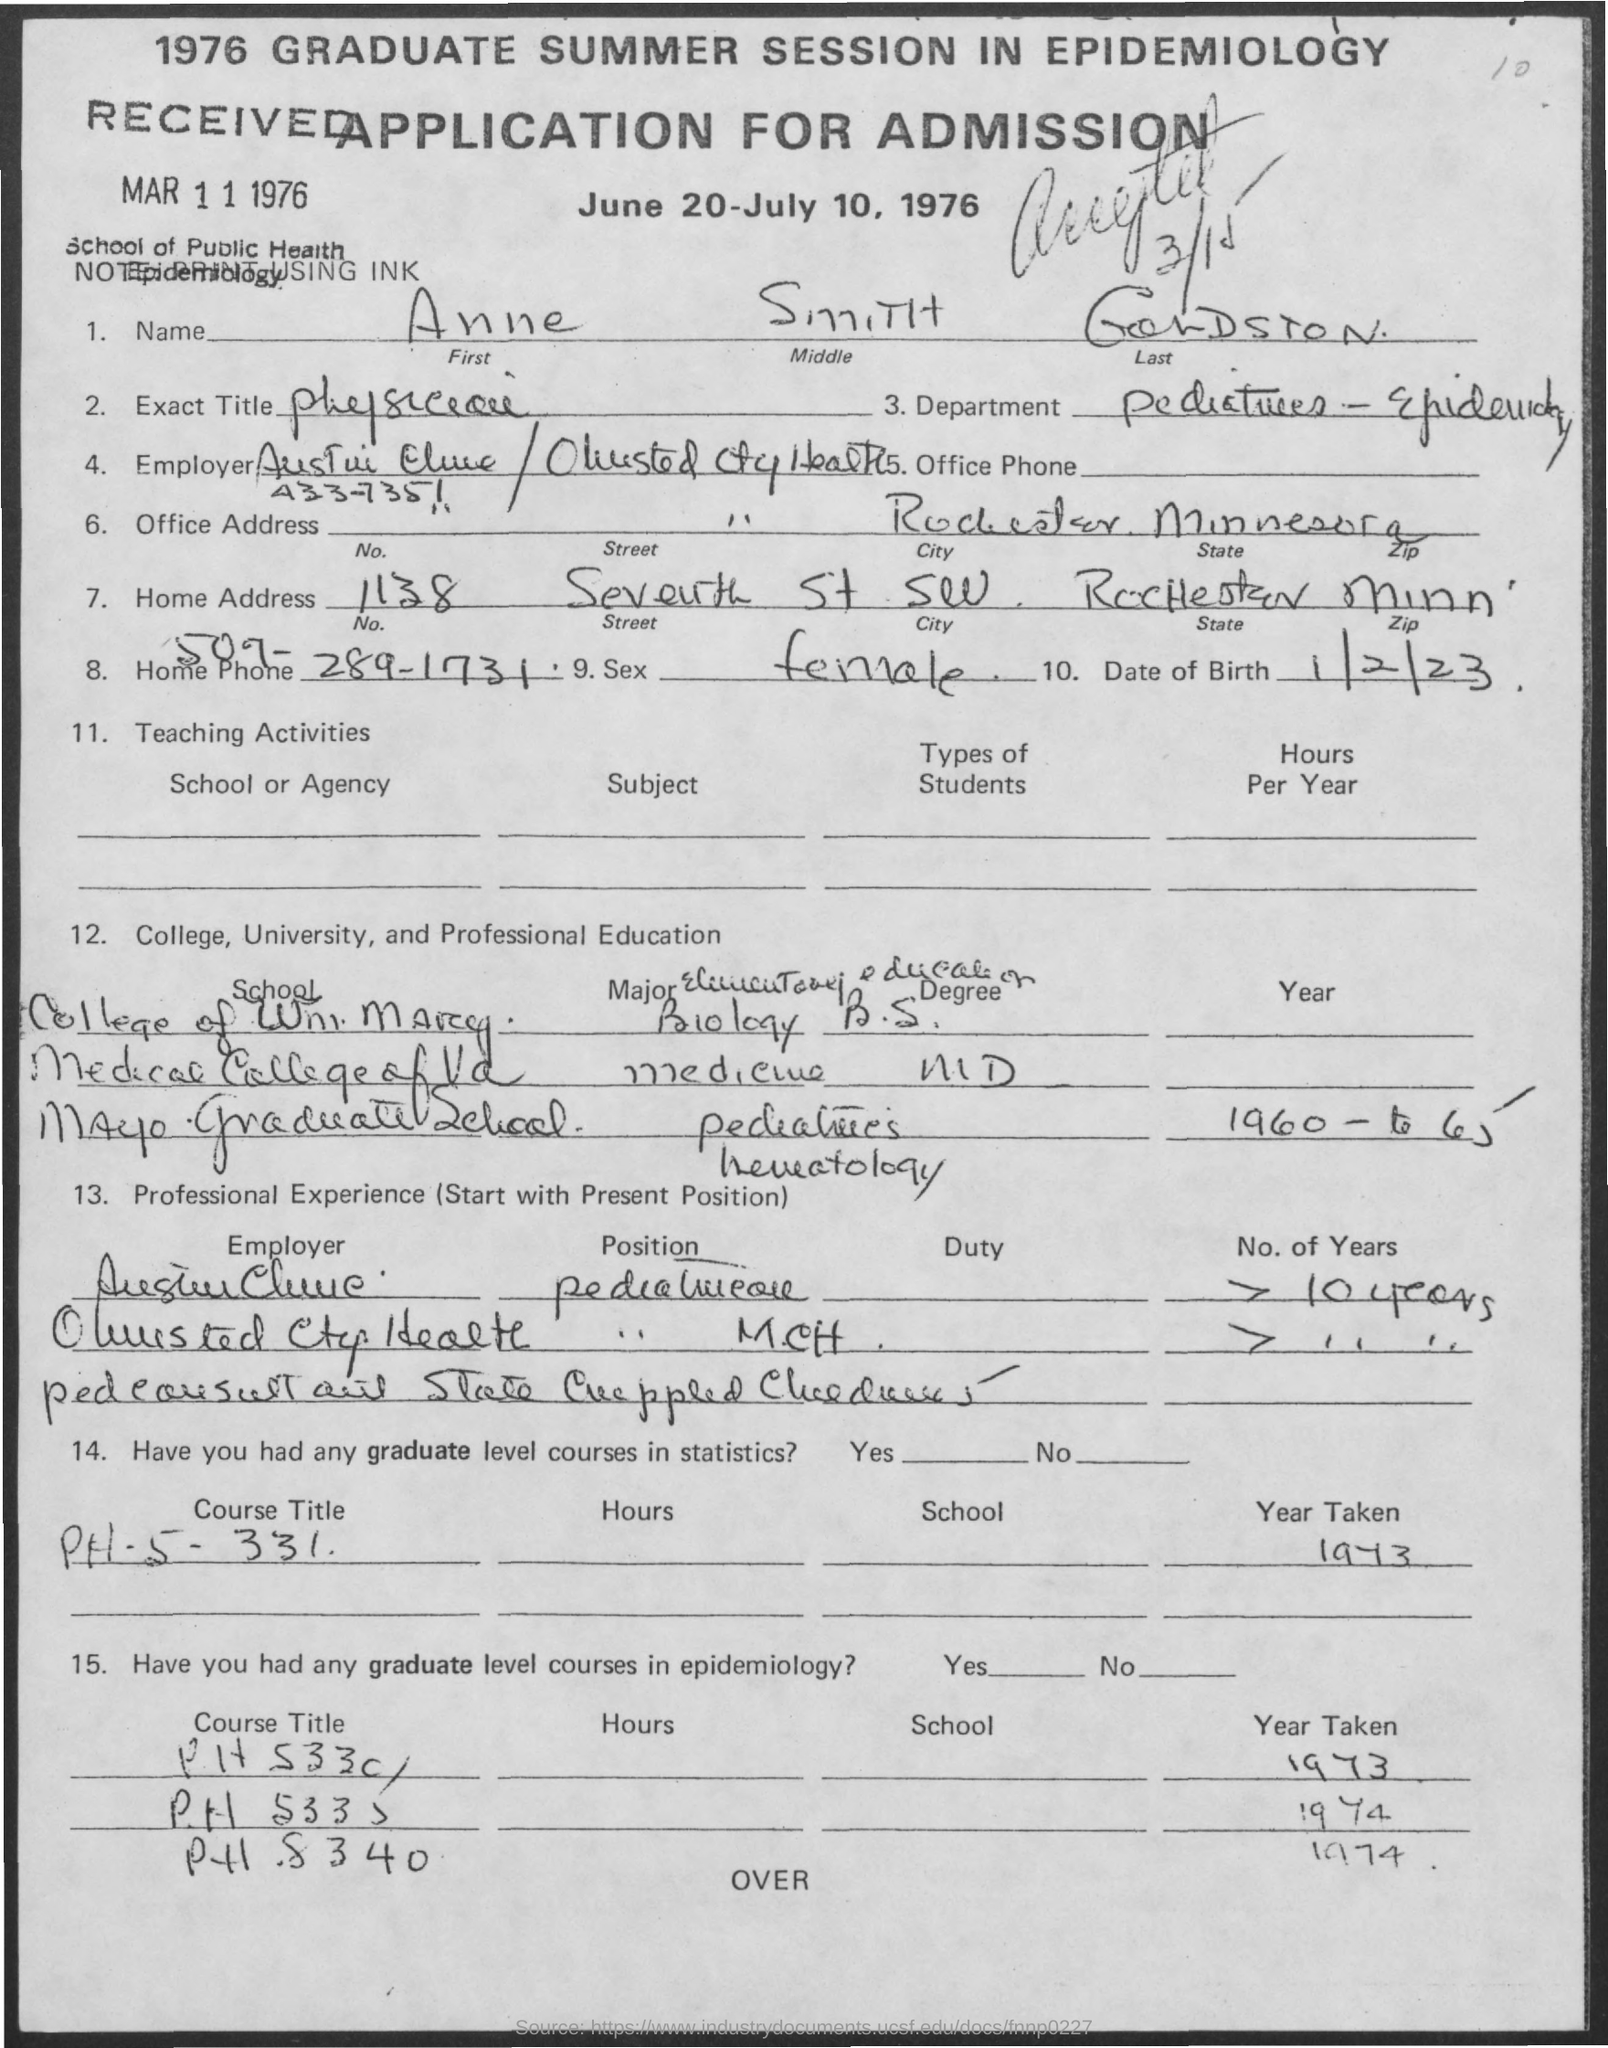What is the Date of Birth of the Applicant?
Provide a succinct answer. 1/2/23. What is the Exact Title ?
Make the answer very short. Physician. 